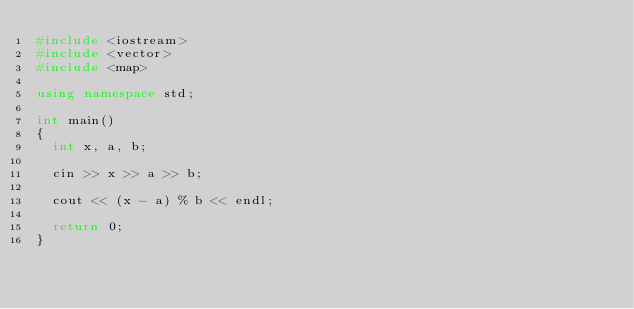<code> <loc_0><loc_0><loc_500><loc_500><_C++_>#include <iostream>
#include <vector>
#include <map>

using namespace std;

int main()
{
	int x, a, b;

	cin >> x >> a >> b;

	cout << (x - a) % b << endl;

	return 0;
}</code> 